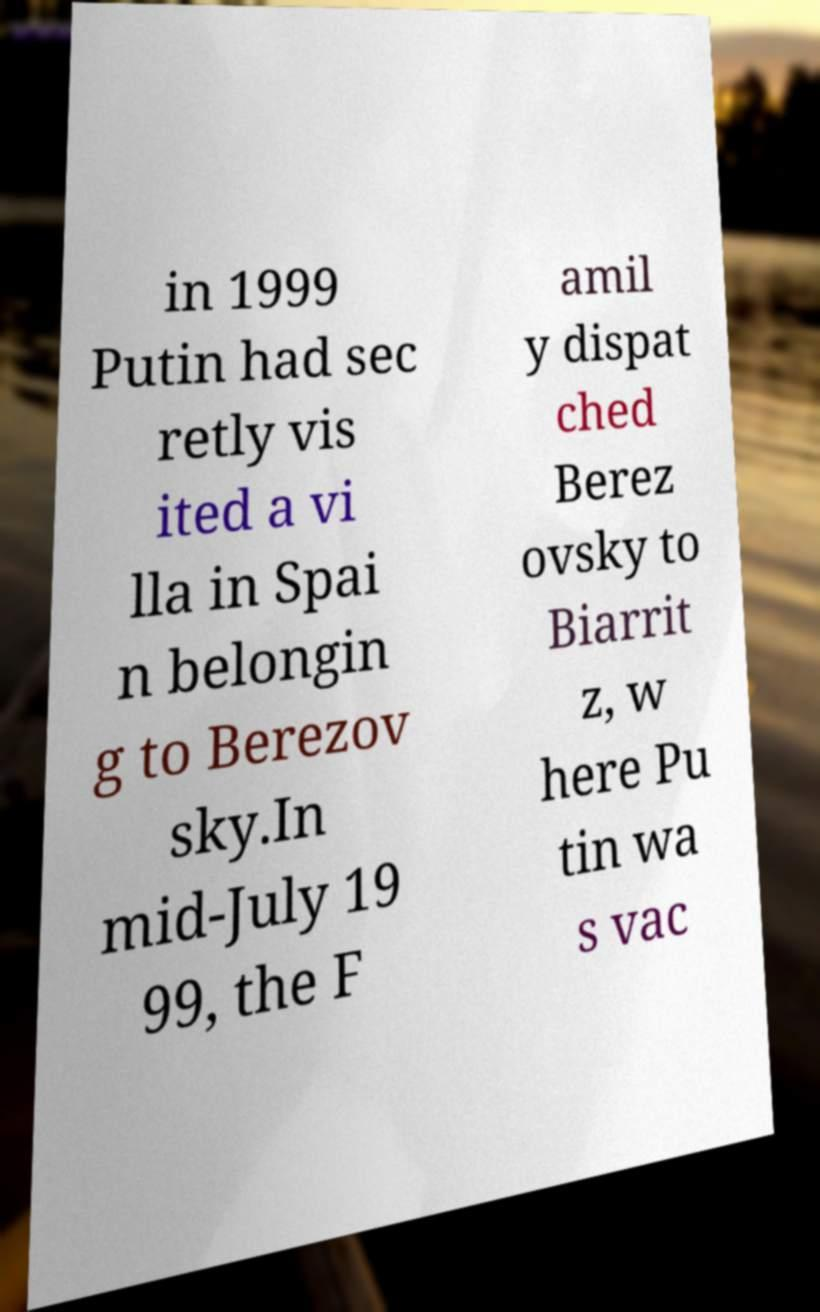Could you extract and type out the text from this image? in 1999 Putin had sec retly vis ited a vi lla in Spai n belongin g to Berezov sky.In mid-July 19 99, the F amil y dispat ched Berez ovsky to Biarrit z, w here Pu tin wa s vac 